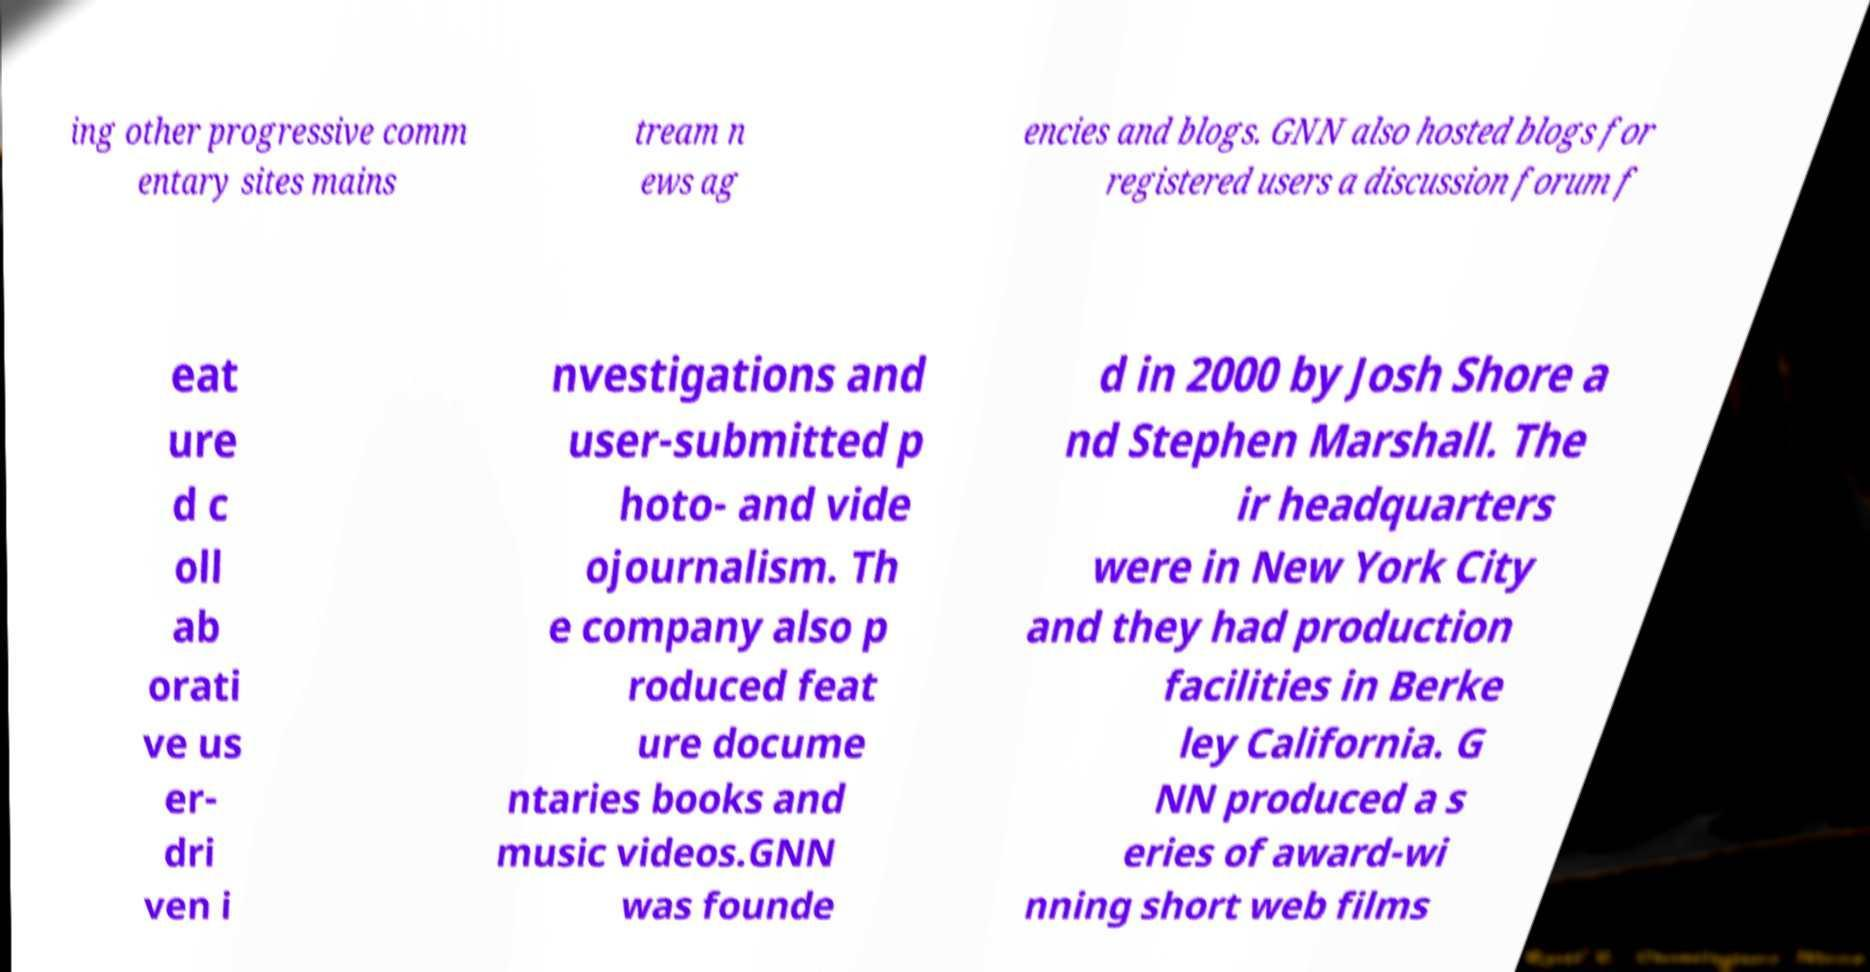Please identify and transcribe the text found in this image. ing other progressive comm entary sites mains tream n ews ag encies and blogs. GNN also hosted blogs for registered users a discussion forum f eat ure d c oll ab orati ve us er- dri ven i nvestigations and user-submitted p hoto- and vide ojournalism. Th e company also p roduced feat ure docume ntaries books and music videos.GNN was founde d in 2000 by Josh Shore a nd Stephen Marshall. The ir headquarters were in New York City and they had production facilities in Berke ley California. G NN produced a s eries of award-wi nning short web films 